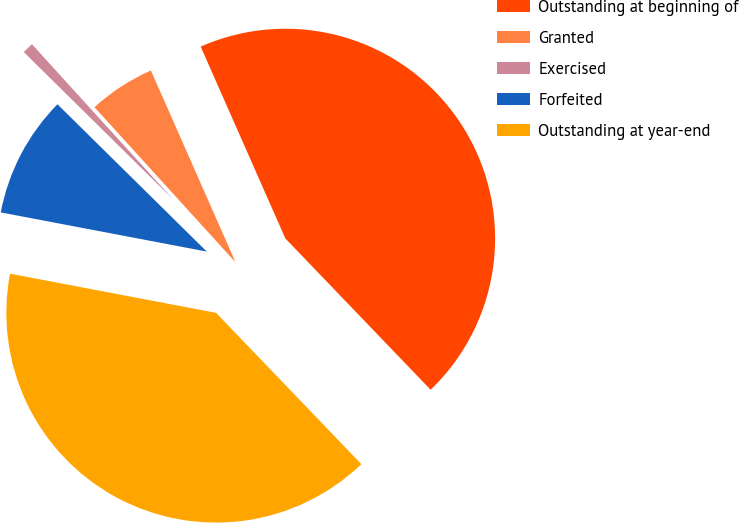Convert chart. <chart><loc_0><loc_0><loc_500><loc_500><pie_chart><fcel>Outstanding at beginning of<fcel>Granted<fcel>Exercised<fcel>Forfeited<fcel>Outstanding at year-end<nl><fcel>44.43%<fcel>5.13%<fcel>0.86%<fcel>9.4%<fcel>40.16%<nl></chart> 